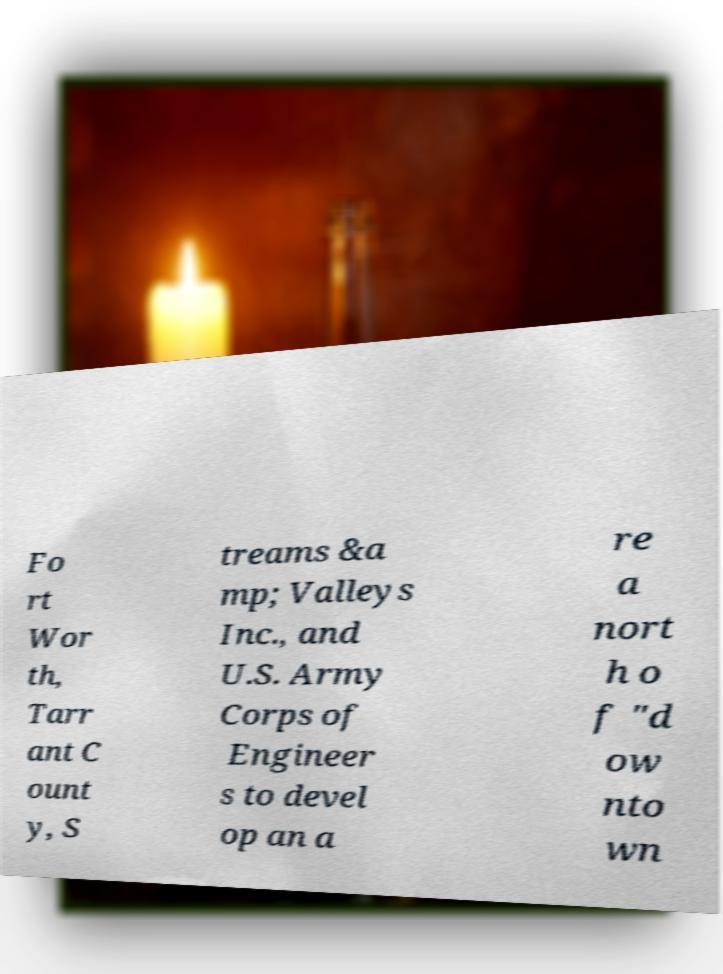Could you extract and type out the text from this image? Fo rt Wor th, Tarr ant C ount y, S treams &a mp; Valleys Inc., and U.S. Army Corps of Engineer s to devel op an a re a nort h o f "d ow nto wn 